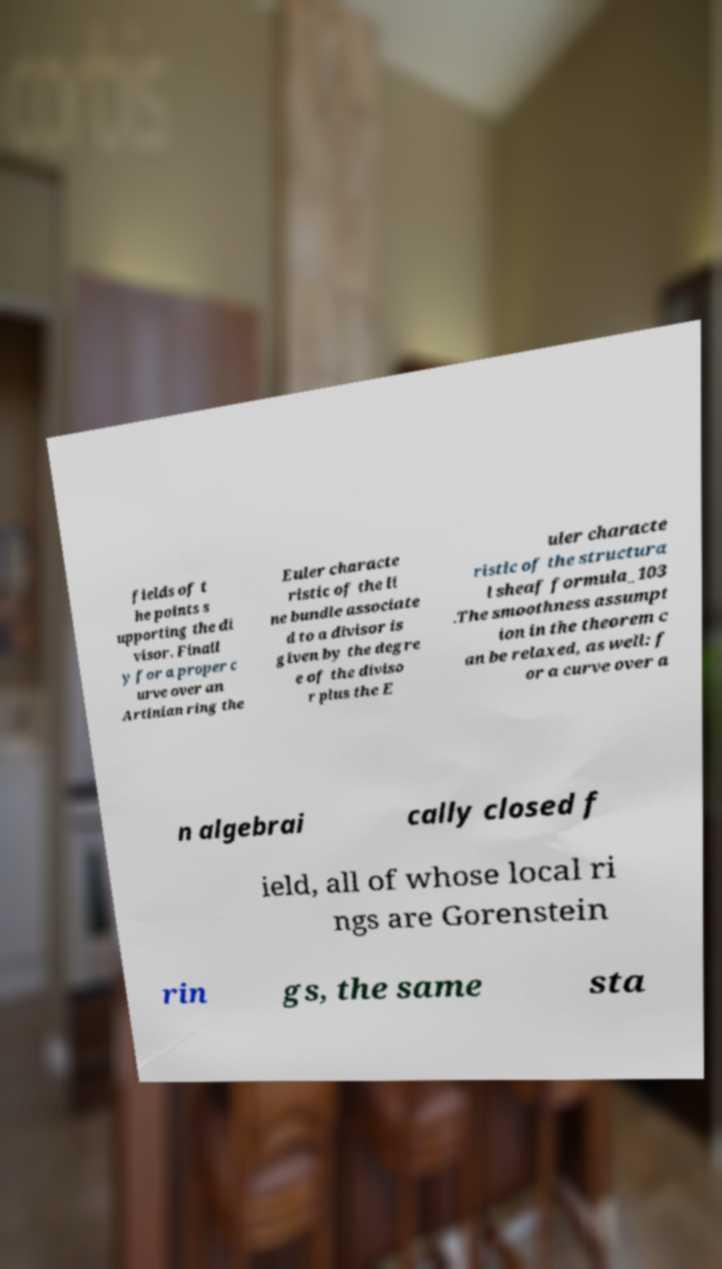Please identify and transcribe the text found in this image. fields of t he points s upporting the di visor. Finall y for a proper c urve over an Artinian ring the Euler characte ristic of the li ne bundle associate d to a divisor is given by the degre e of the diviso r plus the E uler characte ristic of the structura l sheaf formula_103 .The smoothness assumpt ion in the theorem c an be relaxed, as well: f or a curve over a n algebrai cally closed f ield, all of whose local ri ngs are Gorenstein rin gs, the same sta 